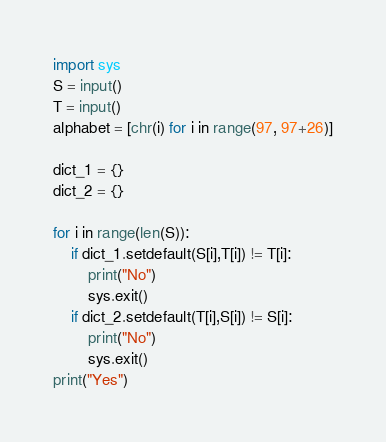<code> <loc_0><loc_0><loc_500><loc_500><_Python_>import sys
S = input()
T = input()
alphabet = [chr(i) for i in range(97, 97+26)]

dict_1 = {}
dict_2 = {}

for i in range(len(S)):
    if dict_1.setdefault(S[i],T[i]) != T[i]:
        print("No")
        sys.exit()
    if dict_2.setdefault(T[i],S[i]) != S[i]:
        print("No")  
        sys.exit()  
print("Yes")</code> 